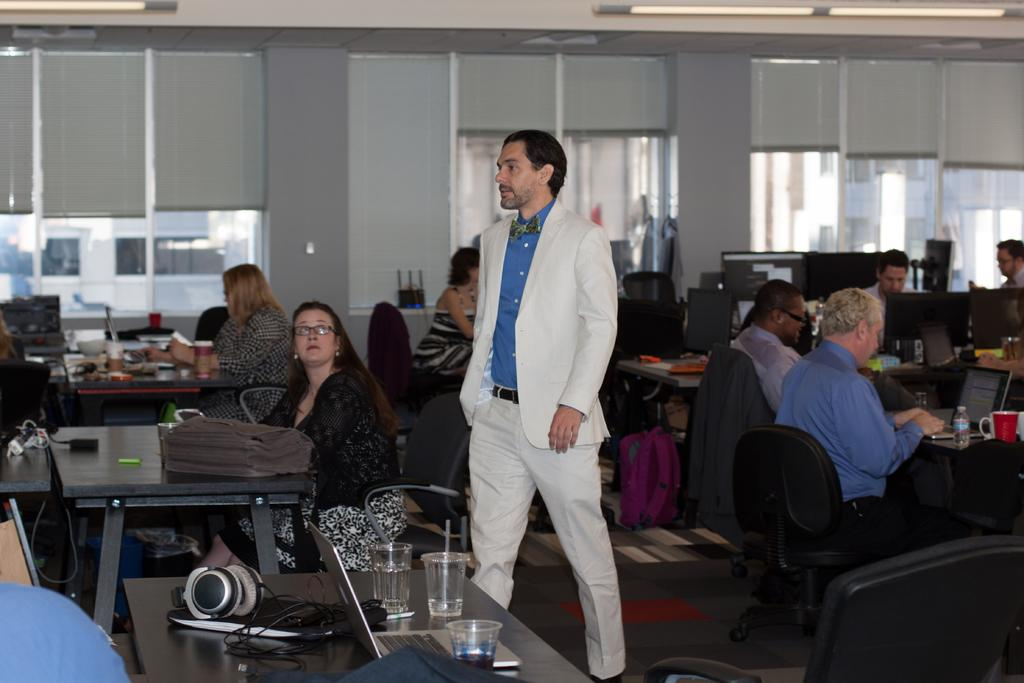What type of space is shown in the image? The image depicts a room. What furniture can be seen in the room? There are tables and chairs in the room. What are the people in the room doing? People are sitting on the chairs. Can you describe the person standing in the center of the room? There is a person wearing a white suit standing in the center of the room. What type of letter is the person holding in the image? There is no letter present in the image; the person is wearing a white suit and standing in the center of the room. Can you describe the sofa in the image? There is no sofa present in the image; the room contains tables and chairs. 